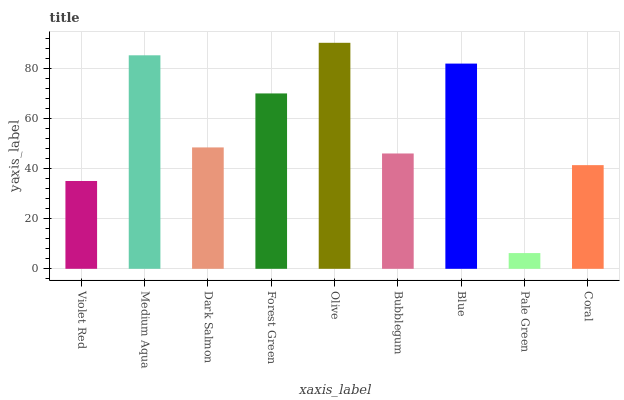Is Pale Green the minimum?
Answer yes or no. Yes. Is Olive the maximum?
Answer yes or no. Yes. Is Medium Aqua the minimum?
Answer yes or no. No. Is Medium Aqua the maximum?
Answer yes or no. No. Is Medium Aqua greater than Violet Red?
Answer yes or no. Yes. Is Violet Red less than Medium Aqua?
Answer yes or no. Yes. Is Violet Red greater than Medium Aqua?
Answer yes or no. No. Is Medium Aqua less than Violet Red?
Answer yes or no. No. Is Dark Salmon the high median?
Answer yes or no. Yes. Is Dark Salmon the low median?
Answer yes or no. Yes. Is Bubblegum the high median?
Answer yes or no. No. Is Bubblegum the low median?
Answer yes or no. No. 